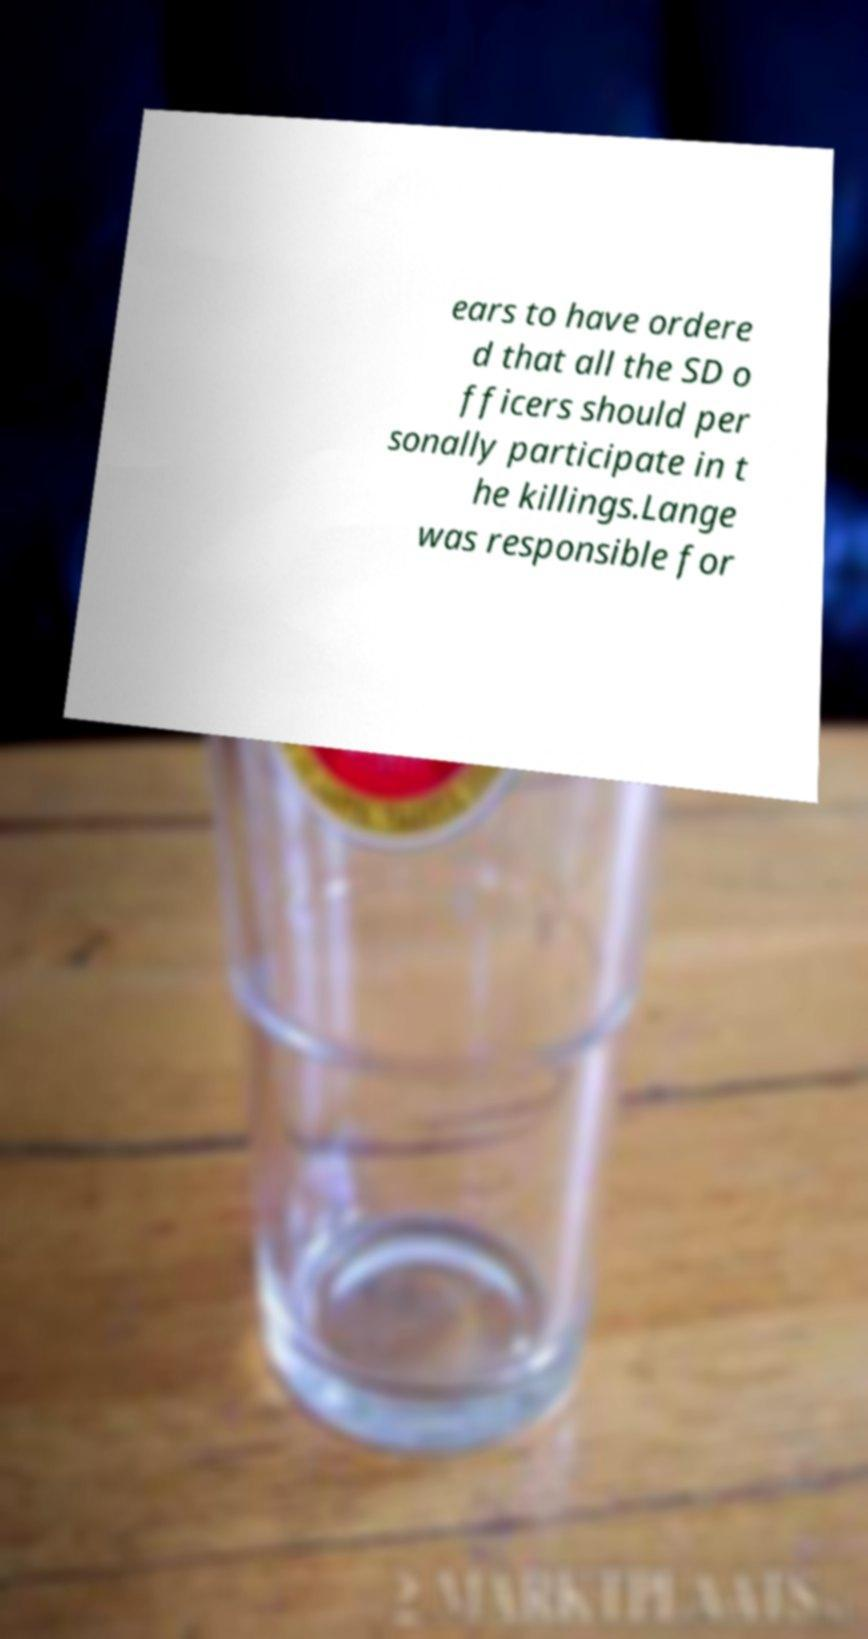Could you extract and type out the text from this image? ears to have ordere d that all the SD o fficers should per sonally participate in t he killings.Lange was responsible for 